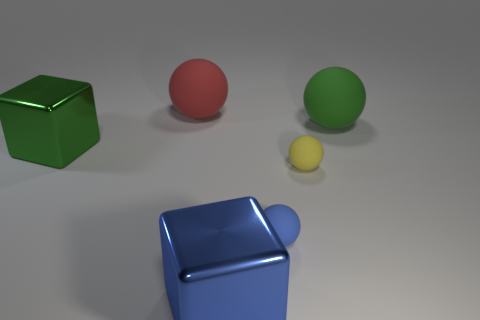There is a green object that is the same material as the big blue object; what is its size?
Your response must be concise. Large. There is a blue rubber object; is it the same shape as the green metal thing that is behind the big blue thing?
Make the answer very short. No. The green metallic object has what size?
Make the answer very short. Large. Are there fewer green matte spheres that are on the left side of the small yellow matte thing than big blue rubber spheres?
Keep it short and to the point. No. How many green matte balls are the same size as the green block?
Give a very brief answer. 1. Is the color of the large shiny thing that is right of the big green metallic cube the same as the tiny rubber object that is left of the yellow thing?
Your answer should be compact. Yes. How many metal blocks are in front of the green metal cube?
Your response must be concise. 1. Is there a red rubber thing of the same shape as the yellow rubber object?
Your answer should be very brief. Yes. What color is the other metallic object that is the same size as the blue metal object?
Your answer should be compact. Green. Is the number of large things that are behind the green rubber sphere less than the number of green things that are behind the yellow matte ball?
Your answer should be very brief. Yes. 